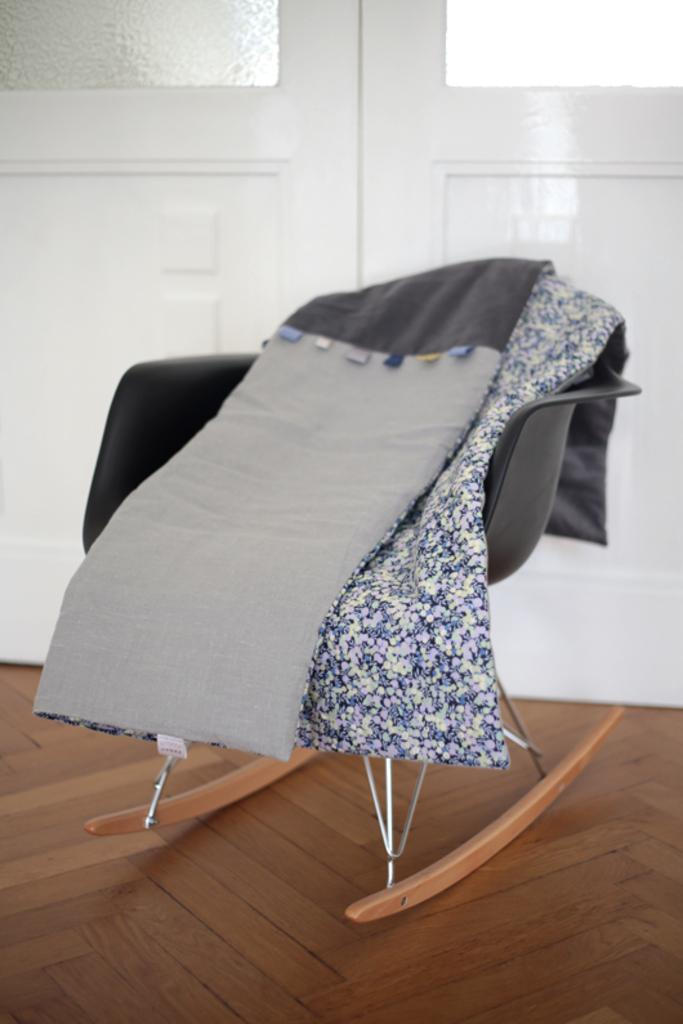What is on the chair in the image? There are clothes on a chair in the image. What type of flooring is visible in the image? The chair is on a wooden floor. What can be seen behind the chair in the image? There is a door with glass panels behind the chair. What type of bushes can be seen growing around the chair in the image? There are no bushes visible in the image; the focus is on the chair, clothes, floor, and door. 